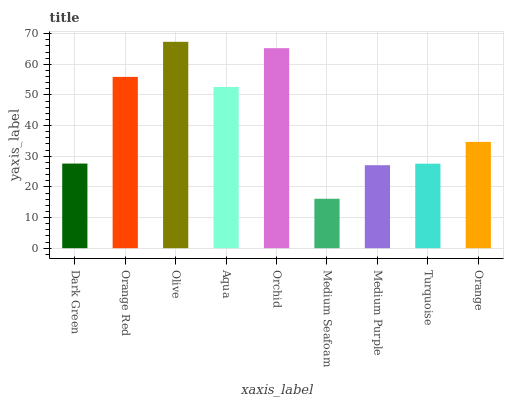Is Orange Red the minimum?
Answer yes or no. No. Is Orange Red the maximum?
Answer yes or no. No. Is Orange Red greater than Dark Green?
Answer yes or no. Yes. Is Dark Green less than Orange Red?
Answer yes or no. Yes. Is Dark Green greater than Orange Red?
Answer yes or no. No. Is Orange Red less than Dark Green?
Answer yes or no. No. Is Orange the high median?
Answer yes or no. Yes. Is Orange the low median?
Answer yes or no. Yes. Is Aqua the high median?
Answer yes or no. No. Is Aqua the low median?
Answer yes or no. No. 